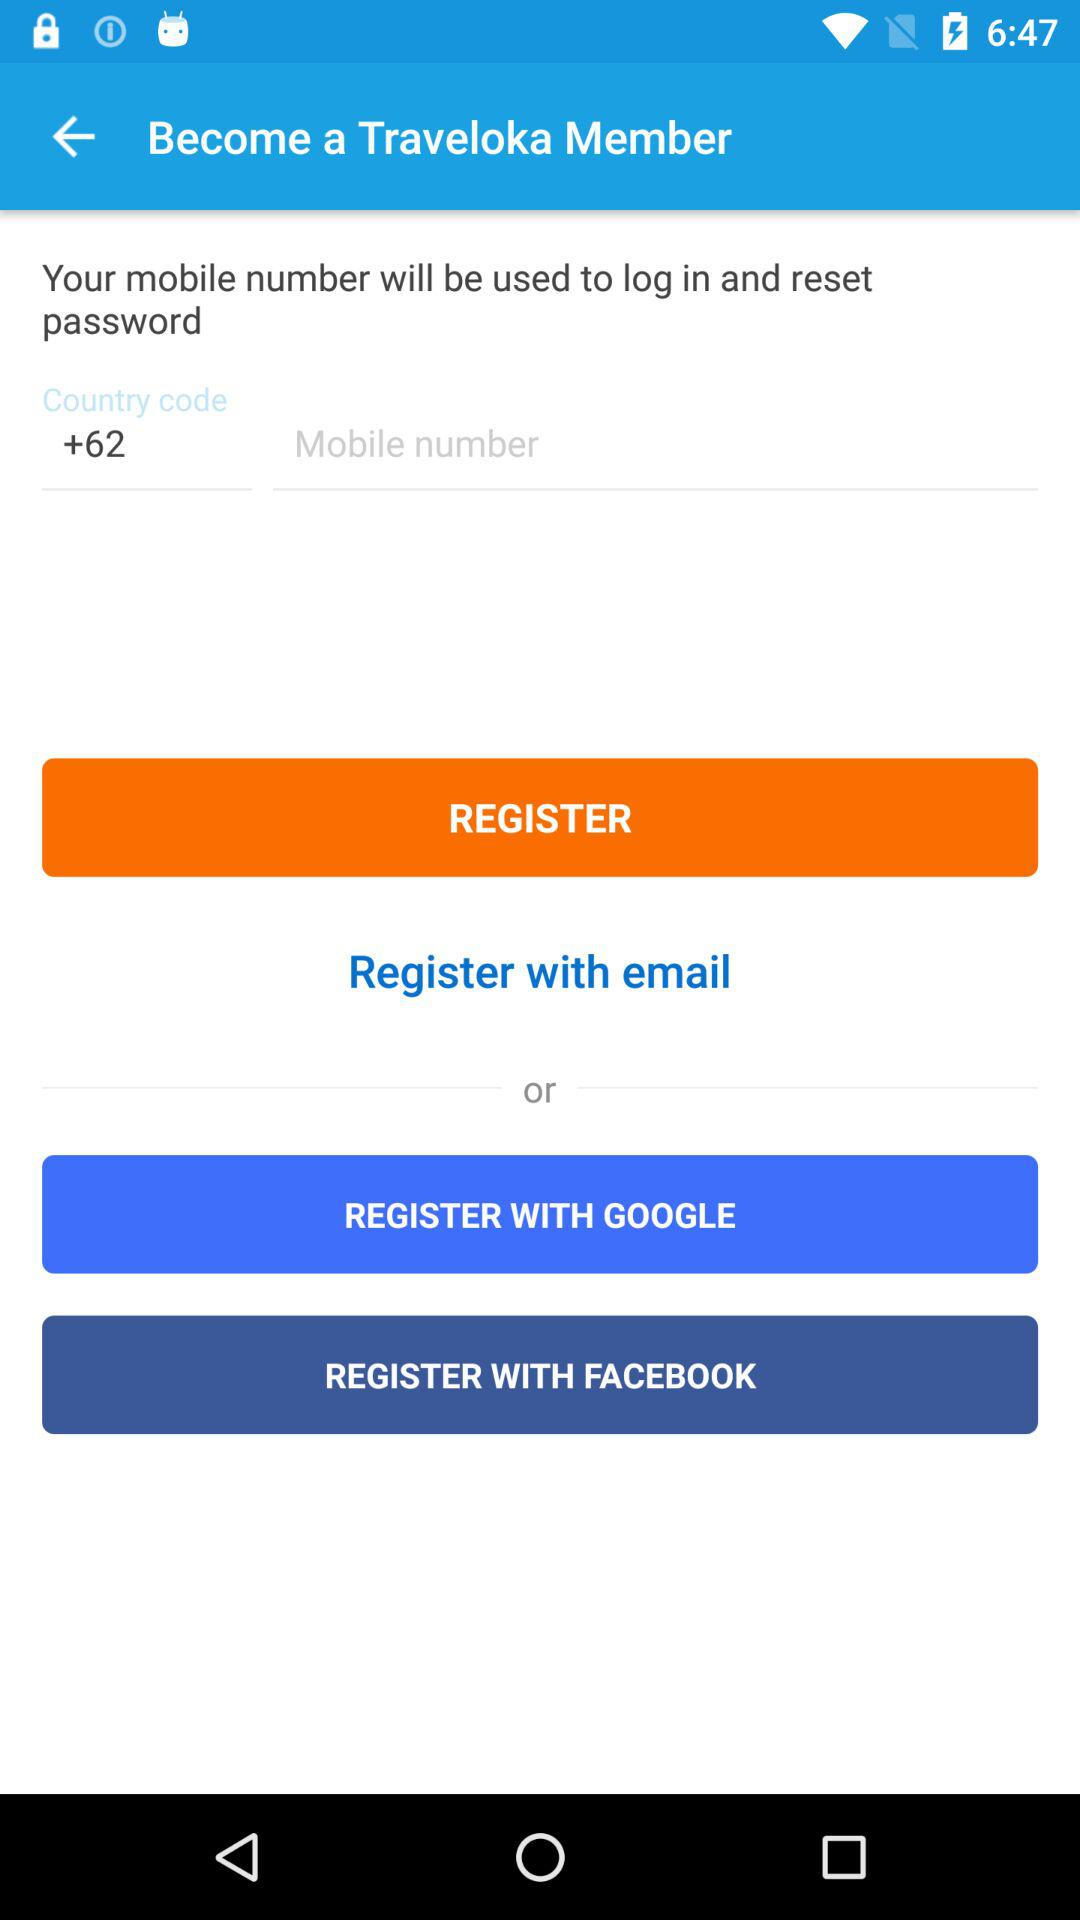What is the entered mobile number?
When the provided information is insufficient, respond with <no answer>. <no answer> 